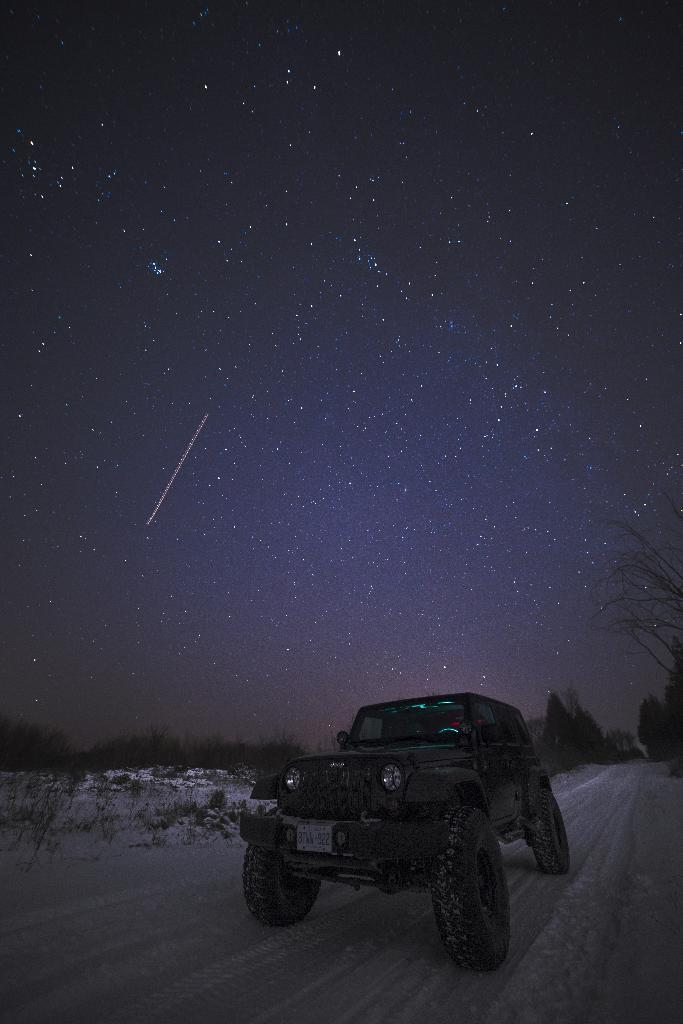What is the main subject of the image? There is a vehicle in the image. What is the condition of the ground where the vehicle is located? The vehicle is on the snow. What can be seen in the background of the image? There are many trees visible in the background. What is visible in the sky in the image? Stars are present in the sky, and the sky is visible in the image. What type of pancake is being served to the slaves in the image? There is no mention of slaves or pancakes in the image; it features a vehicle on the snow with trees and stars visible in the background. 